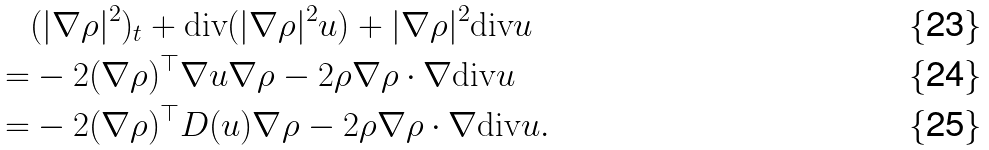<formula> <loc_0><loc_0><loc_500><loc_500>& ( | \nabla \rho | ^ { 2 } ) _ { t } + \text {div} ( | \nabla \rho | ^ { 2 } u ) + | \nabla \rho | ^ { 2 } \text {div} u \\ = & - 2 ( \nabla \rho ) ^ { \top } \nabla u \nabla \rho - 2 \rho \nabla \rho \cdot \nabla \text {div} u \\ = & - 2 ( \nabla \rho ) ^ { \top } D ( u ) \nabla \rho - 2 \rho \nabla \rho \cdot \nabla \text {div} u .</formula> 